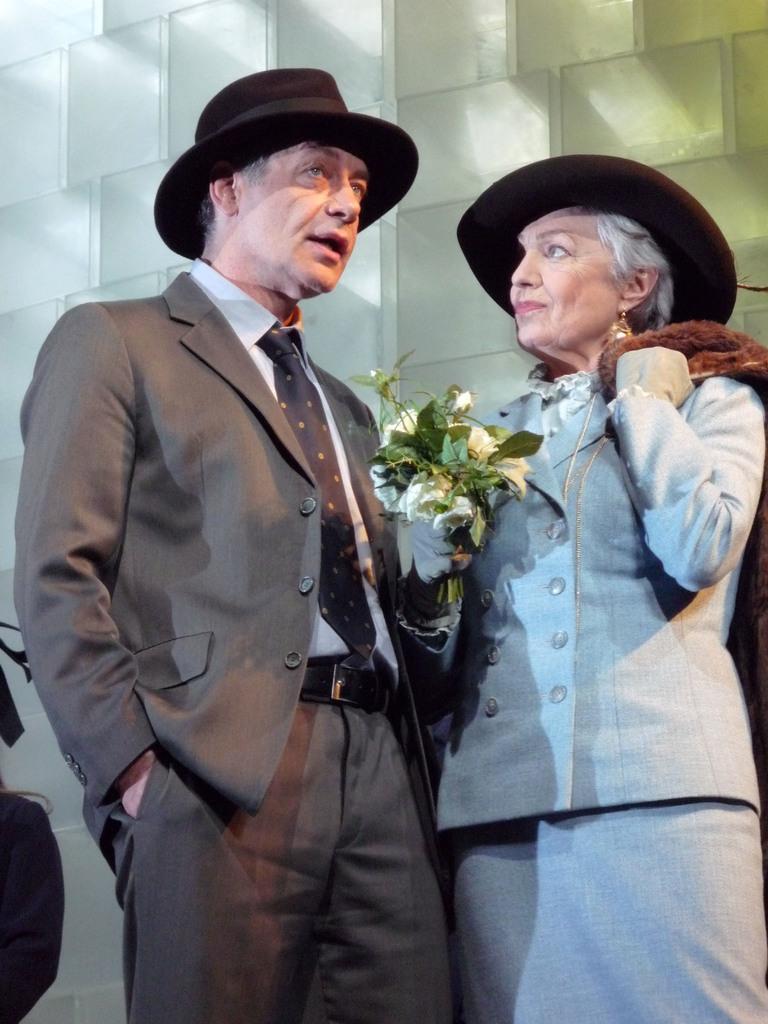Can you describe this image briefly? This picture describe about the old man wearing a brown color suit with hat standing and talking with a woman wearing grey color coat standing beside him and holding a white flowers in hand. In the background we can see white color brick wall. 